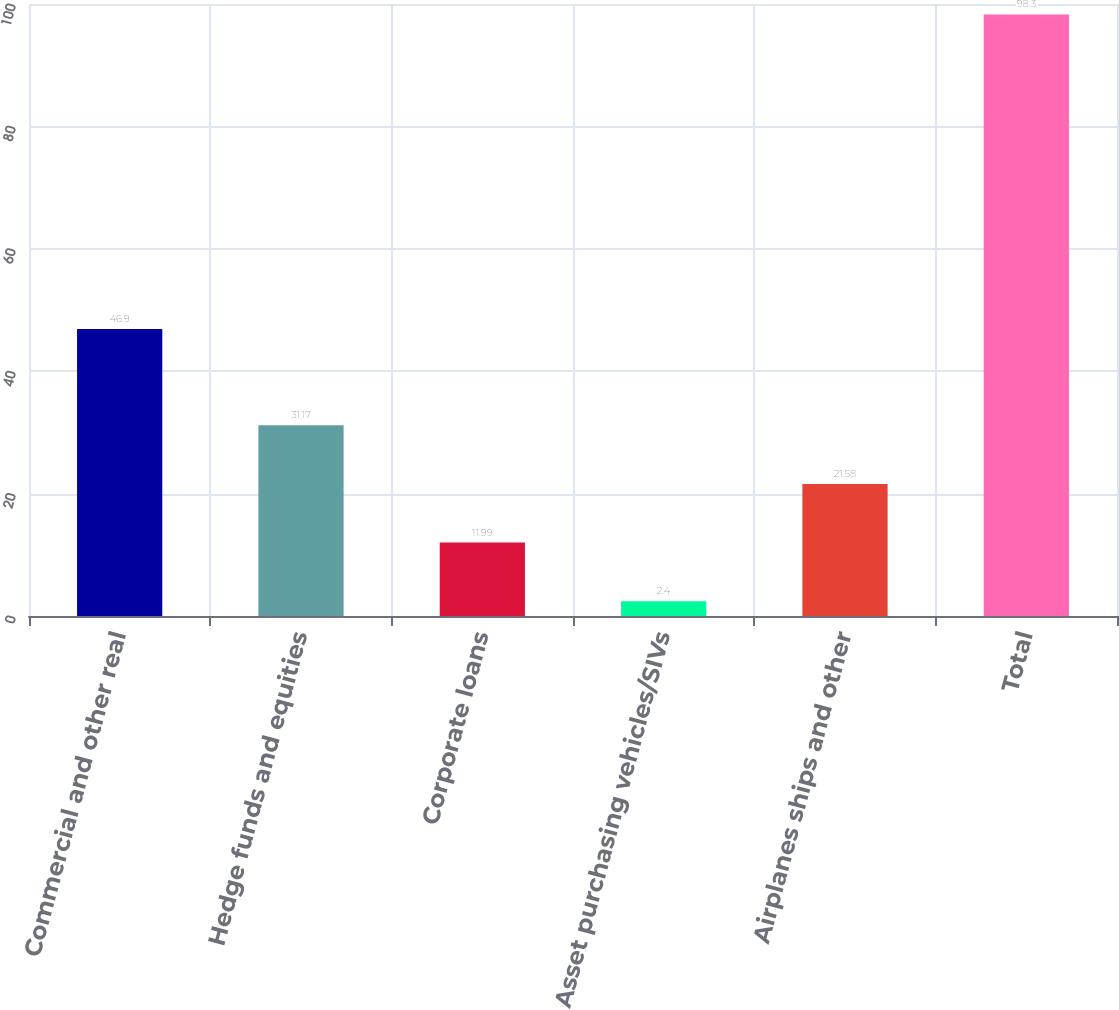Convert chart to OTSL. <chart><loc_0><loc_0><loc_500><loc_500><bar_chart><fcel>Commercial and other real<fcel>Hedge funds and equities<fcel>Corporate loans<fcel>Asset purchasing vehicles/SIVs<fcel>Airplanes ships and other<fcel>Total<nl><fcel>46.9<fcel>31.17<fcel>11.99<fcel>2.4<fcel>21.58<fcel>98.3<nl></chart> 